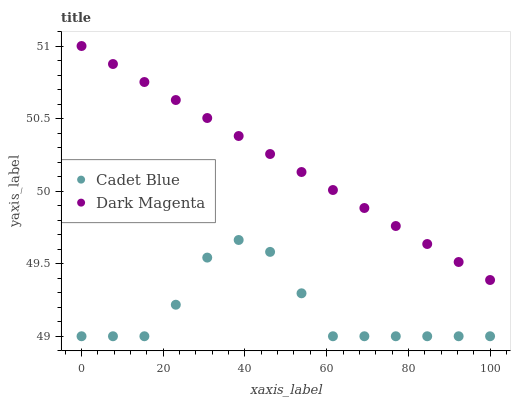Does Cadet Blue have the minimum area under the curve?
Answer yes or no. Yes. Does Dark Magenta have the maximum area under the curve?
Answer yes or no. Yes. Does Dark Magenta have the minimum area under the curve?
Answer yes or no. No. Is Dark Magenta the smoothest?
Answer yes or no. Yes. Is Cadet Blue the roughest?
Answer yes or no. Yes. Is Dark Magenta the roughest?
Answer yes or no. No. Does Cadet Blue have the lowest value?
Answer yes or no. Yes. Does Dark Magenta have the lowest value?
Answer yes or no. No. Does Dark Magenta have the highest value?
Answer yes or no. Yes. Is Cadet Blue less than Dark Magenta?
Answer yes or no. Yes. Is Dark Magenta greater than Cadet Blue?
Answer yes or no. Yes. Does Cadet Blue intersect Dark Magenta?
Answer yes or no. No. 